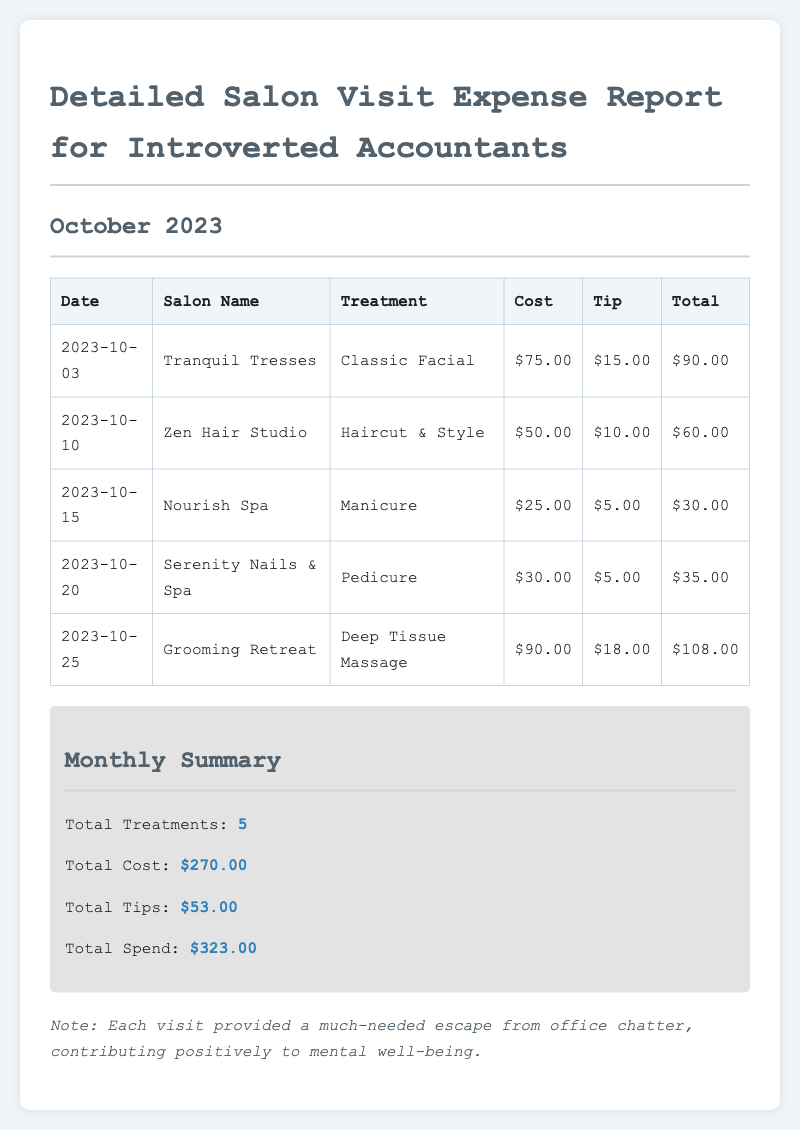What is the date of the first salon visit? The first salon visit occurred on October 3, 2023, as listed in the table.
Answer: October 3, 2023 How much did the haircut & style cost? The cost for the haircut & style treatment on October 10, 2023, is specified as $50.00.
Answer: $50.00 What was the total amount spent on tips? The total tips for the month can be found in the summary section, totaling $53.00.
Answer: $53.00 How many treatments were received in total? The total number of treatments is stated in the summary section as 5.
Answer: 5 What treatment was received at Serenity Nails & Spa? The treatment received at Serenity Nails & Spa on October 20, 2023, was a pedicure.
Answer: Pedicure What is the total spend for the month? The total spend for the month is summarized in the document as $323.00.
Answer: $323.00 What is the maximum cost of a single treatment? The maximum cost among the treatments listed is $90.00 for the deep tissue massage.
Answer: $90.00 Which salon provided the classic facial? The classic facial treatment was provided by Tranquil Tresses, as shown in the table.
Answer: Tranquil Tresses What is an additional note provided in the document? An additional note discusses the mental well-being benefits from the salon visits, indicating they provided an escape from office chatter.
Answer: Each visit provided a much-needed escape from office chatter 